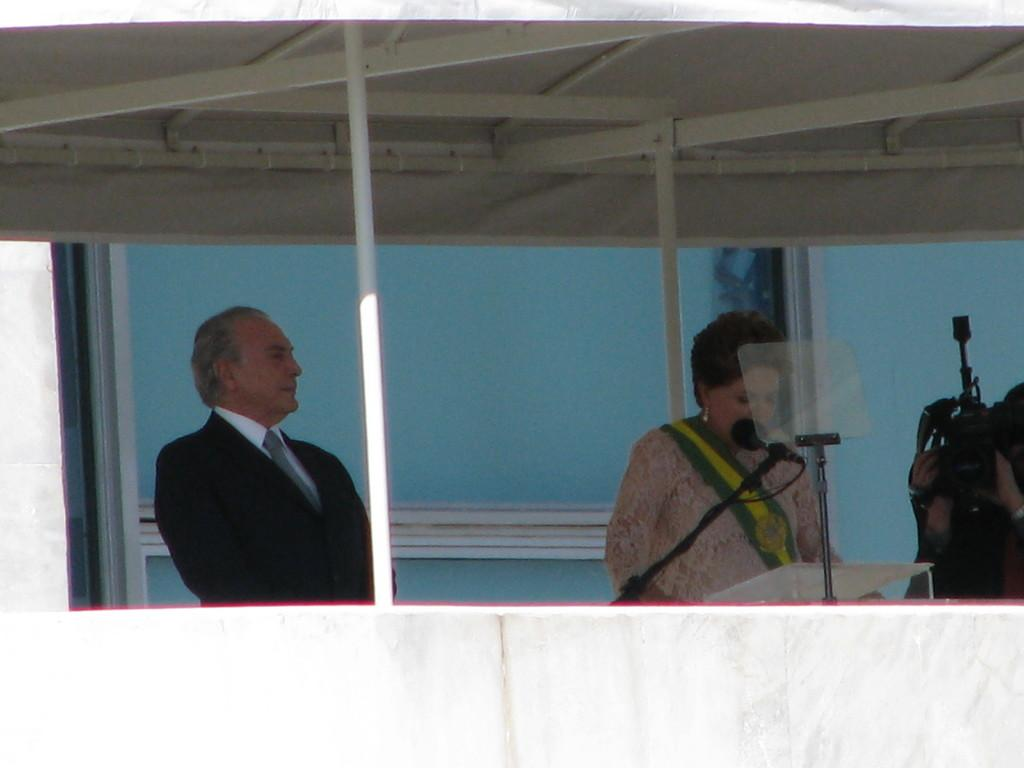Who is the main subject in the image? There is a woman in the image. What is the woman doing in the image? The woman is giving a speech. Is there anyone else present in the image? Yes, there is a man standing beside the woman. What is the photographer doing in the image? The photographer is on the right side of the image, presumably capturing the event. What can be seen behind the woman in the image? There is a blue surface behind the woman. What is the latest news about the woman's income in the image? There is no information about the woman's income in the image, as the focus is on her giving a speech. 